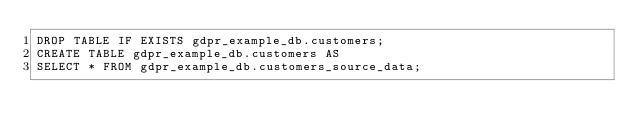Convert code to text. <code><loc_0><loc_0><loc_500><loc_500><_SQL_>DROP TABLE IF EXISTS gdpr_example_db.customers;
CREATE TABLE gdpr_example_db.customers AS
SELECT * FROM gdpr_example_db.customers_source_data;

</code> 